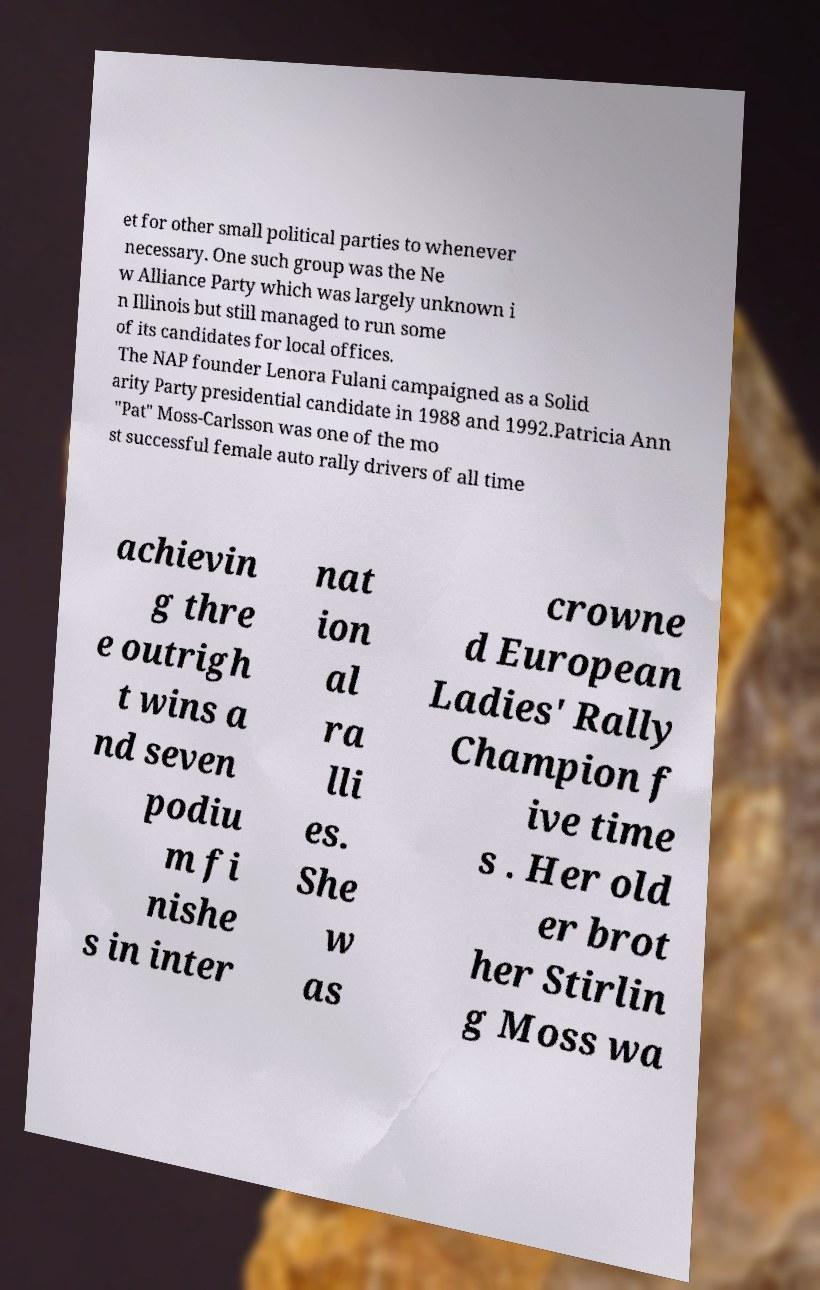There's text embedded in this image that I need extracted. Can you transcribe it verbatim? et for other small political parties to whenever necessary. One such group was the Ne w Alliance Party which was largely unknown i n Illinois but still managed to run some of its candidates for local offices. The NAP founder Lenora Fulani campaigned as a Solid arity Party presidential candidate in 1988 and 1992.Patricia Ann "Pat" Moss-Carlsson was one of the mo st successful female auto rally drivers of all time achievin g thre e outrigh t wins a nd seven podiu m fi nishe s in inter nat ion al ra lli es. She w as crowne d European Ladies' Rally Champion f ive time s . Her old er brot her Stirlin g Moss wa 